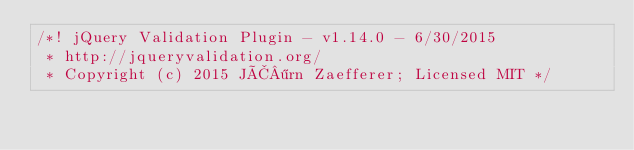Convert code to text. <code><loc_0><loc_0><loc_500><loc_500><_JavaScript_>/*! jQuery Validation Plugin - v1.14.0 - 6/30/2015
 * http://jqueryvalidation.org/
 * Copyright (c) 2015 JÃ¶rn Zaefferer; Licensed MIT */</code> 